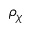Convert formula to latex. <formula><loc_0><loc_0><loc_500><loc_500>\rho _ { \chi }</formula> 